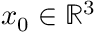Convert formula to latex. <formula><loc_0><loc_0><loc_500><loc_500>x _ { 0 } \in \mathbb { R } ^ { 3 }</formula> 